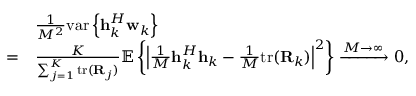<formula> <loc_0><loc_0><loc_500><loc_500>\begin{array} { r l } & { \frac { 1 } { M ^ { 2 } } v a r \left \{ { h } _ { k } ^ { H } { w } _ { k } \right \} } \\ { = } & { \frac { K } { { \sum _ { j = 1 } ^ { K } t r ( { R } _ { j } ) } } \mathbb { E } \left \{ \left | \frac { 1 } { M } { h } _ { k } ^ { H } { h } _ { k } - \frac { 1 } { M } t r ( { R } _ { k } ) \right | ^ { 2 } \right \} \xrightarrow { M \rightarrow \infty } 0 , } \end{array}</formula> 